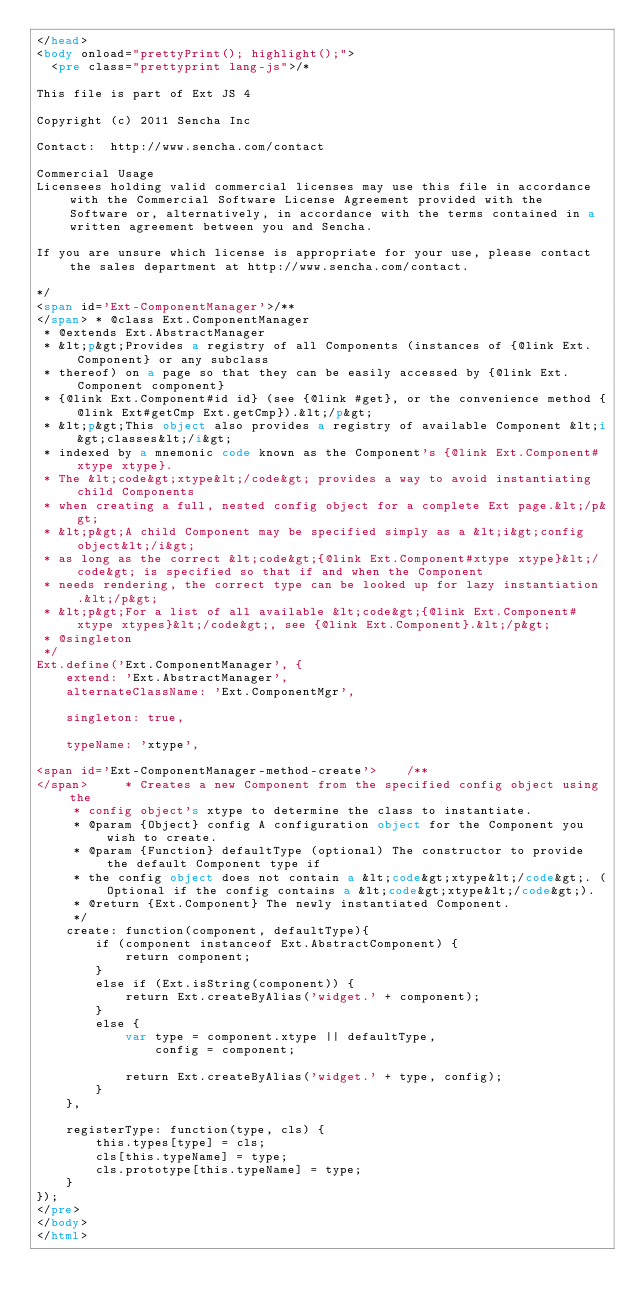<code> <loc_0><loc_0><loc_500><loc_500><_HTML_></head>
<body onload="prettyPrint(); highlight();">
  <pre class="prettyprint lang-js">/*

This file is part of Ext JS 4

Copyright (c) 2011 Sencha Inc

Contact:  http://www.sencha.com/contact

Commercial Usage
Licensees holding valid commercial licenses may use this file in accordance with the Commercial Software License Agreement provided with the Software or, alternatively, in accordance with the terms contained in a written agreement between you and Sencha.

If you are unsure which license is appropriate for your use, please contact the sales department at http://www.sencha.com/contact.

*/
<span id='Ext-ComponentManager'>/**
</span> * @class Ext.ComponentManager
 * @extends Ext.AbstractManager
 * &lt;p&gt;Provides a registry of all Components (instances of {@link Ext.Component} or any subclass
 * thereof) on a page so that they can be easily accessed by {@link Ext.Component component}
 * {@link Ext.Component#id id} (see {@link #get}, or the convenience method {@link Ext#getCmp Ext.getCmp}).&lt;/p&gt;
 * &lt;p&gt;This object also provides a registry of available Component &lt;i&gt;classes&lt;/i&gt;
 * indexed by a mnemonic code known as the Component's {@link Ext.Component#xtype xtype}.
 * The &lt;code&gt;xtype&lt;/code&gt; provides a way to avoid instantiating child Components
 * when creating a full, nested config object for a complete Ext page.&lt;/p&gt;
 * &lt;p&gt;A child Component may be specified simply as a &lt;i&gt;config object&lt;/i&gt;
 * as long as the correct &lt;code&gt;{@link Ext.Component#xtype xtype}&lt;/code&gt; is specified so that if and when the Component
 * needs rendering, the correct type can be looked up for lazy instantiation.&lt;/p&gt;
 * &lt;p&gt;For a list of all available &lt;code&gt;{@link Ext.Component#xtype xtypes}&lt;/code&gt;, see {@link Ext.Component}.&lt;/p&gt;
 * @singleton
 */
Ext.define('Ext.ComponentManager', {
    extend: 'Ext.AbstractManager',
    alternateClassName: 'Ext.ComponentMgr',
    
    singleton: true,
    
    typeName: 'xtype',
    
<span id='Ext-ComponentManager-method-create'>    /**
</span>     * Creates a new Component from the specified config object using the
     * config object's xtype to determine the class to instantiate.
     * @param {Object} config A configuration object for the Component you wish to create.
     * @param {Function} defaultType (optional) The constructor to provide the default Component type if
     * the config object does not contain a &lt;code&gt;xtype&lt;/code&gt;. (Optional if the config contains a &lt;code&gt;xtype&lt;/code&gt;).
     * @return {Ext.Component} The newly instantiated Component.
     */
    create: function(component, defaultType){
        if (component instanceof Ext.AbstractComponent) {
            return component;
        }
        else if (Ext.isString(component)) {
            return Ext.createByAlias('widget.' + component);
        }
        else {
            var type = component.xtype || defaultType,
                config = component;
            
            return Ext.createByAlias('widget.' + type, config);
        }
    },

    registerType: function(type, cls) {
        this.types[type] = cls;
        cls[this.typeName] = type;
        cls.prototype[this.typeName] = type;
    }
});
</pre>
</body>
</html>
</code> 